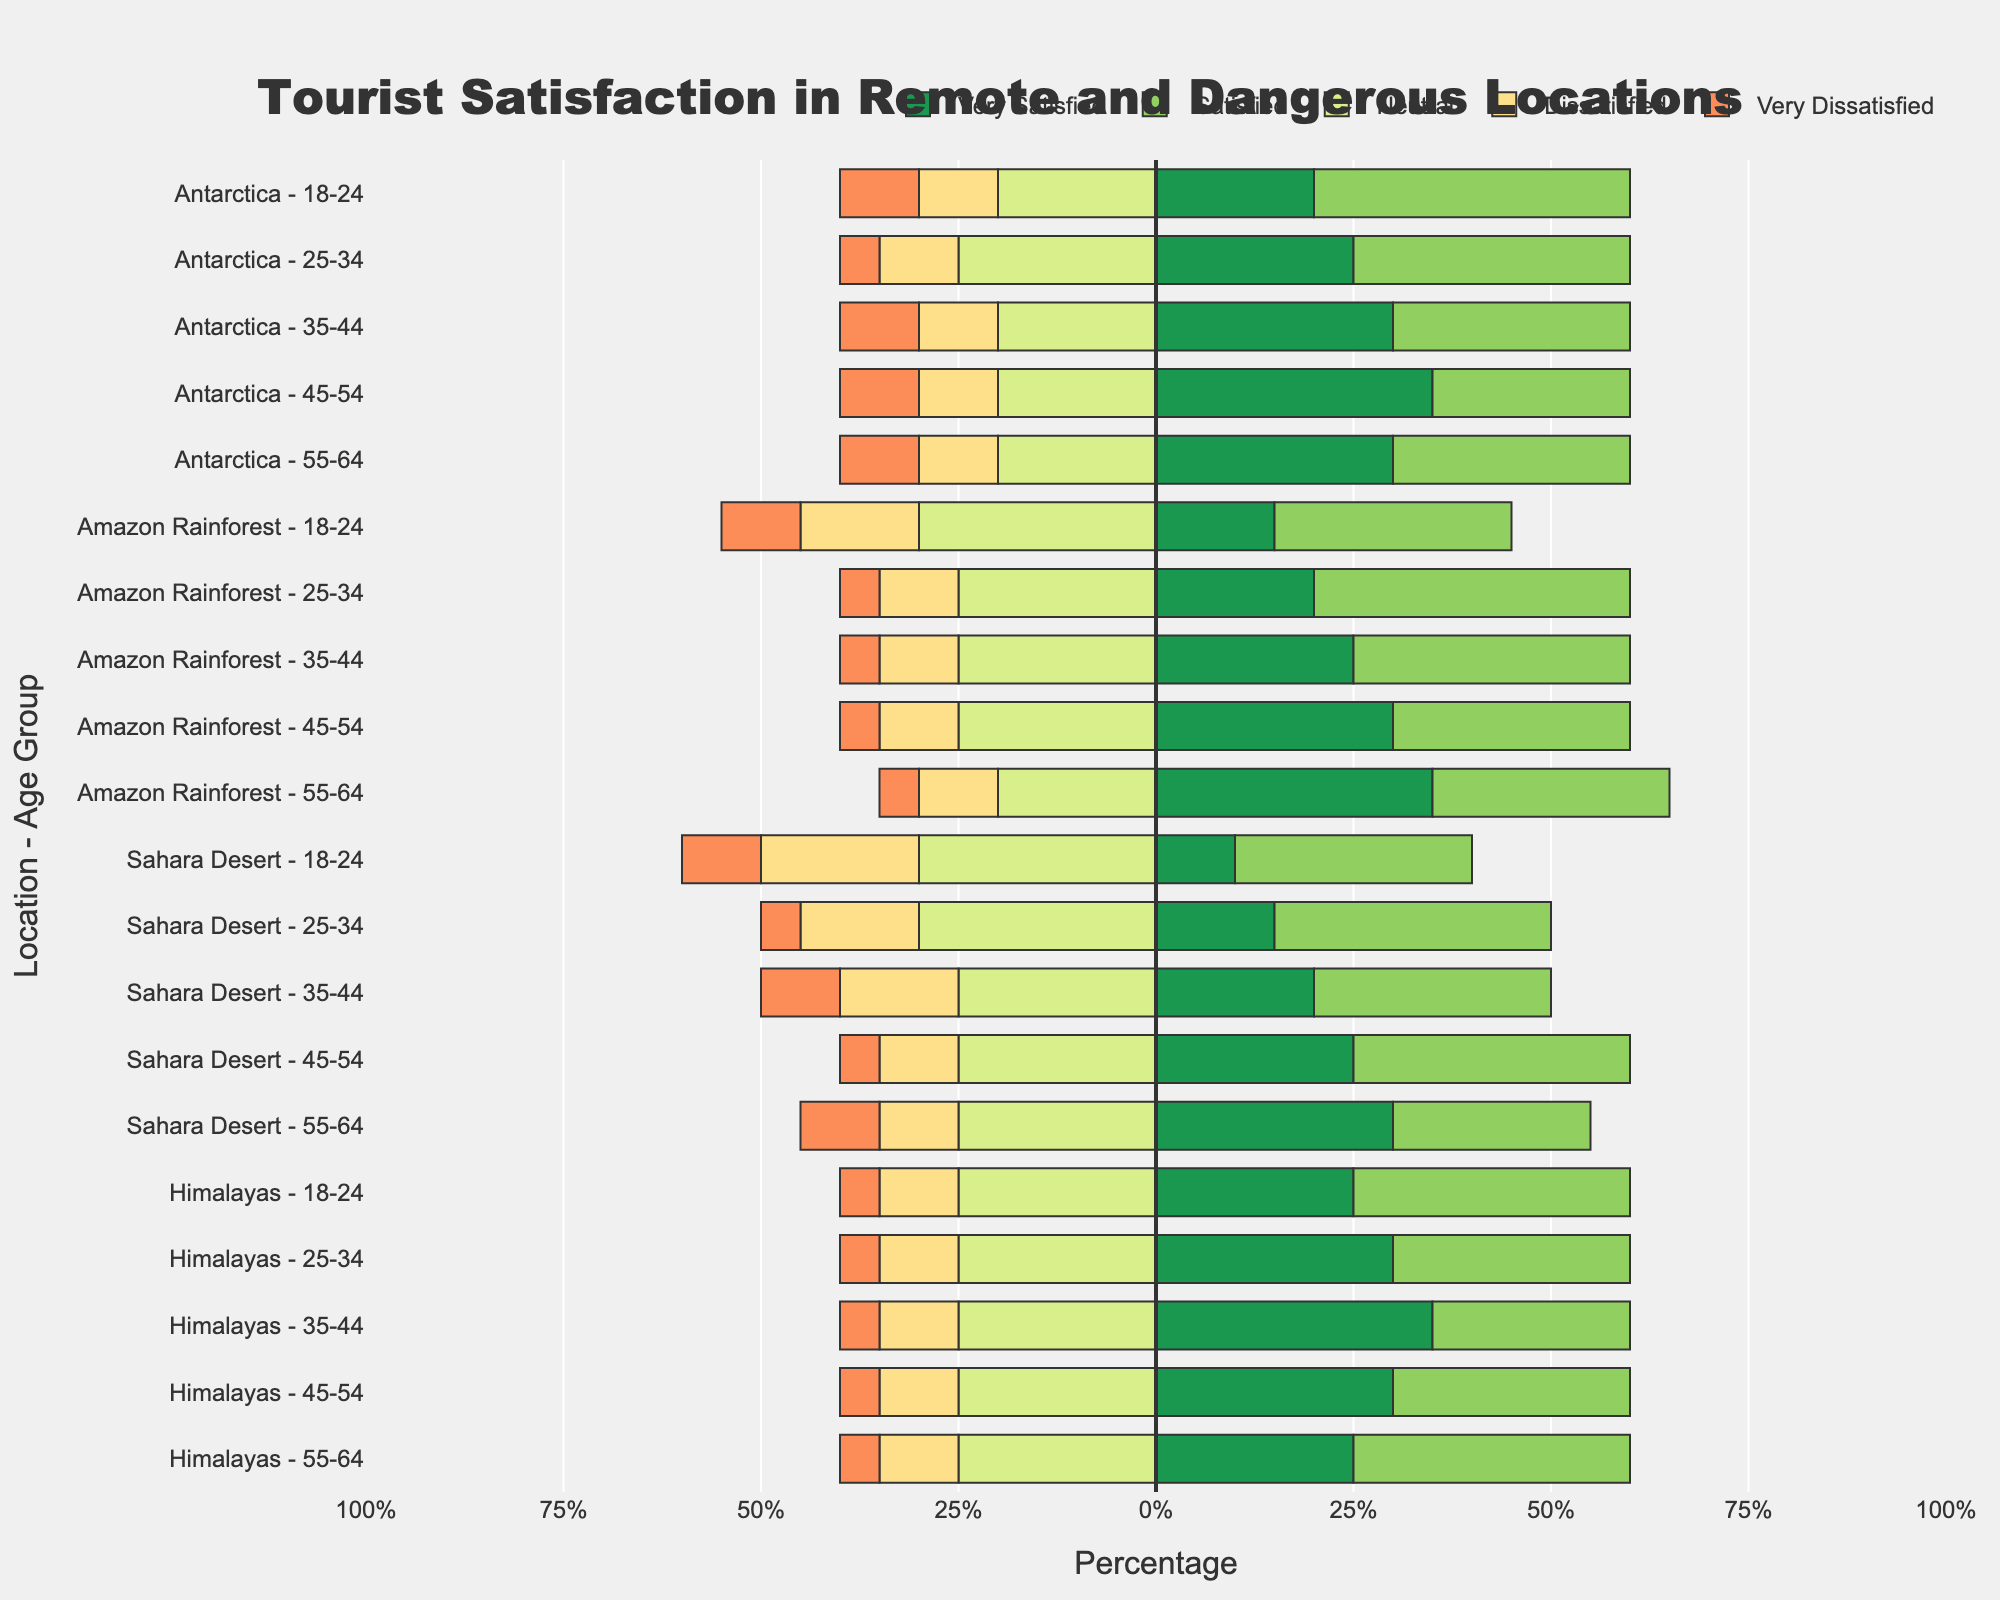What is the percentage of tourists aged 25-34 who are very satisfied with their visit to the Himalayas? First, find the bar corresponding to tourists aged 25-34 visiting the Himalayas. This bar shows that 30% of tourists in this group are very satisfied.
Answer: 30% In the Amazon Rainforest, which age group has the highest combined percentage of 'Very Satisfied' and 'Satisfied' tourists? Add the percentages of 'Very Satisfied' and 'Satisfied' for each age group in the Amazon Rainforest:
- 18-24: 15% + 30% = 45%
- 25-34: 20% + 40% = 60%
- 35-44: 25% + 35% = 60%
- 45-54: 30% + 30% = 60%
- 55-64: 35% + 30% = 65%
The highest combined percentage is 65% for the 55-64 age group.
Answer: 55-64 How does the percentage of 'Very Dissatisfied' tourists aged 18-24 in the Sahara Desert compare to those aged 18-24 in Antarctica? Compare the 'Very Dissatisfied' percentage for 18-24 age group in both regions:
- Sahara Desert: 10%
- Antarctica: 10%
Both groups have the same percentage of 'Very Dissatisfied' tourists.
Answer: Equal Which age group has the greatest percentage difference between 'Satisfied' and 'Dissatisfied' tourists in Antarctica? Subtract the 'Dissatisfied' percentage from the 'Satisfied' percentage for each age group in Antarctica:
- 18-24: 40% - 10% = 30%
- 25-34: 35% - 10% = 25%
- 35-44: 30% - 10% = 20%
- 45-54: 25% - 10% = 15%
- 55-64: 30% - 10% = 20%
The greatest difference is 30% for the 18-24 age group.
Answer: 18-24 What is the total percentage of 'Neutral' tourists across all age groups in the Sahara Desert? Add the 'Neutral' percentages for all age groups in the Sahara Desert:
- 18-24: 30%
- 25-34: 30%
- 35-44: 25%
- 45-54: 25%
- 55-64: 25%
The total is 30% + 30% + 25% + 25% + 25% = 135%.
Answer: 135% In which location do tourists aged 45-54 have the highest satisfaction (by combining 'Very Satisfied' and 'Satisfied')? Calculate the combined 'Very Satisfied' and 'Satisfied' percentages for tourists aged 45-54 in each location:
- Antarctica: 35% + 25% = 60%
- Amazon Rainforest: 30% + 30% = 60%
- Sahara Desert: 25% + 35% = 60%
- Himalayas: 30% + 30% = 60%
All locations have the same combined percentage of satisfaction for this age group.
Answer: Equal What is the most common satisfaction level among tourists aged 35-44 visiting the Himalayas? Evaluate the percentages for each satisfaction level for tourists aged 35-44 visiting the Himalayas:
- Very Satisfied: 35%
- Satisfied: 25%
- Neutral: 25%
- Dissatisfied: 10%
- Very Dissatisfied: 5%
The highest percentage is for 'Very Satisfied' at 35%.
Answer: Very Satisfied 